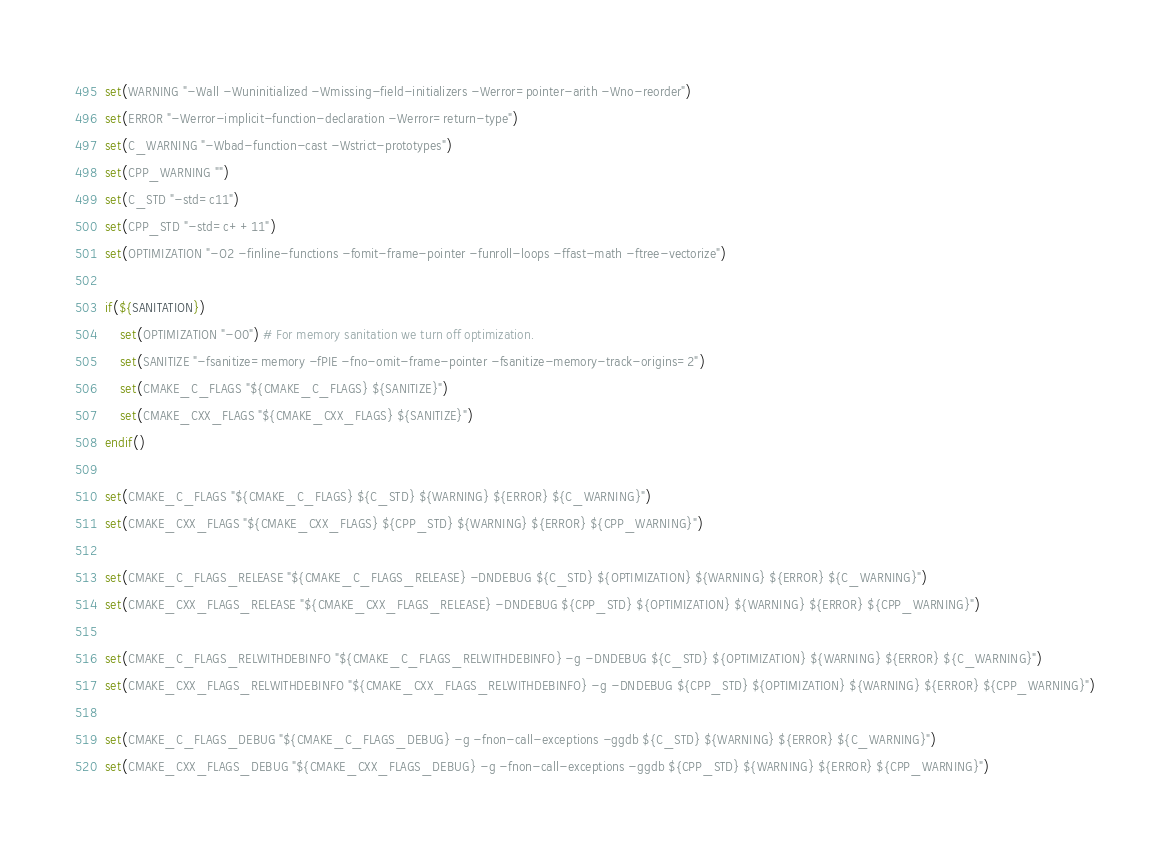Convert code to text. <code><loc_0><loc_0><loc_500><loc_500><_CMake_>set(WARNING "-Wall -Wuninitialized -Wmissing-field-initializers -Werror=pointer-arith -Wno-reorder")
set(ERROR "-Werror-implicit-function-declaration -Werror=return-type")
set(C_WARNING "-Wbad-function-cast -Wstrict-prototypes")
set(CPP_WARNING "")
set(C_STD "-std=c11")
set(CPP_STD "-std=c++11")
set(OPTIMIZATION "-O2 -finline-functions -fomit-frame-pointer -funroll-loops -ffast-math -ftree-vectorize")

if(${SANITATION})
    set(OPTIMIZATION "-O0") # For memory sanitation we turn off optimization.
    set(SANITIZE "-fsanitize=memory -fPIE -fno-omit-frame-pointer -fsanitize-memory-track-origins=2")
    set(CMAKE_C_FLAGS "${CMAKE_C_FLAGS} ${SANITIZE}")
    set(CMAKE_CXX_FLAGS "${CMAKE_CXX_FLAGS} ${SANITIZE}")
endif()

set(CMAKE_C_FLAGS "${CMAKE_C_FLAGS} ${C_STD} ${WARNING} ${ERROR} ${C_WARNING}")
set(CMAKE_CXX_FLAGS "${CMAKE_CXX_FLAGS} ${CPP_STD} ${WARNING} ${ERROR} ${CPP_WARNING}")

set(CMAKE_C_FLAGS_RELEASE "${CMAKE_C_FLAGS_RELEASE} -DNDEBUG ${C_STD} ${OPTIMIZATION} ${WARNING} ${ERROR} ${C_WARNING}")
set(CMAKE_CXX_FLAGS_RELEASE "${CMAKE_CXX_FLAGS_RELEASE} -DNDEBUG ${CPP_STD} ${OPTIMIZATION} ${WARNING} ${ERROR} ${CPP_WARNING}")

set(CMAKE_C_FLAGS_RELWITHDEBINFO "${CMAKE_C_FLAGS_RELWITHDEBINFO} -g -DNDEBUG ${C_STD} ${OPTIMIZATION} ${WARNING} ${ERROR} ${C_WARNING}")
set(CMAKE_CXX_FLAGS_RELWITHDEBINFO "${CMAKE_CXX_FLAGS_RELWITHDEBINFO} -g -DNDEBUG ${CPP_STD} ${OPTIMIZATION} ${WARNING} ${ERROR} ${CPP_WARNING}")

set(CMAKE_C_FLAGS_DEBUG "${CMAKE_C_FLAGS_DEBUG} -g -fnon-call-exceptions -ggdb ${C_STD} ${WARNING} ${ERROR} ${C_WARNING}")
set(CMAKE_CXX_FLAGS_DEBUG "${CMAKE_CXX_FLAGS_DEBUG} -g -fnon-call-exceptions -ggdb ${CPP_STD} ${WARNING} ${ERROR} ${CPP_WARNING}")
</code> 